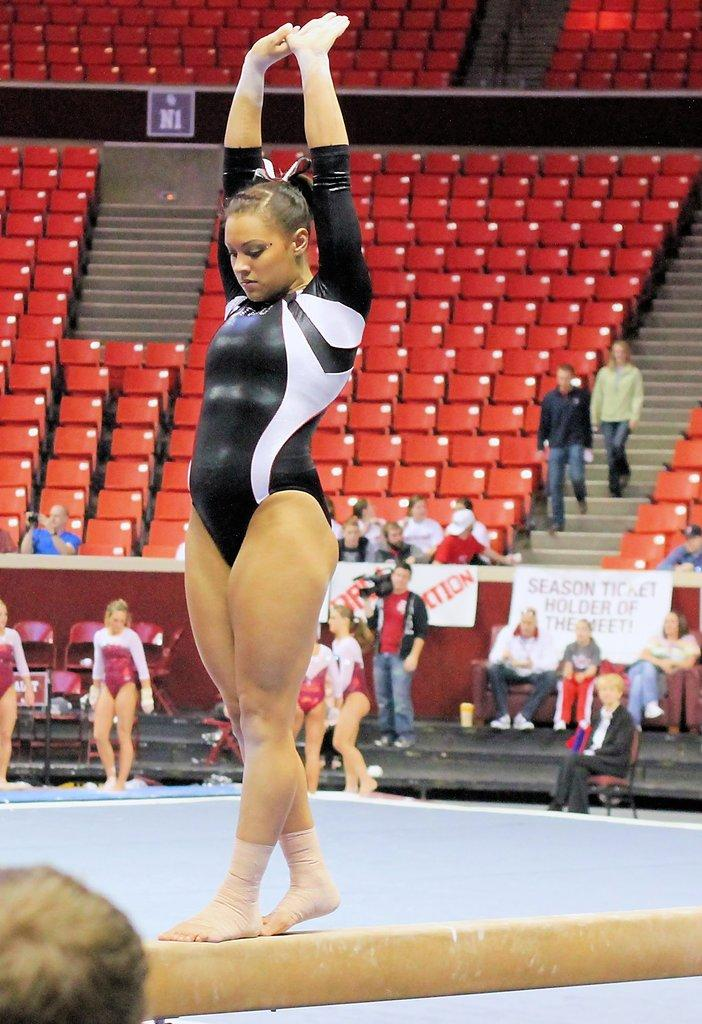Who is the main subject in the image? There is a woman in the image. What is the woman wearing? The woman is wearing a black dress. What is the woman doing in the image? The woman is standing on an object. Can you describe the background of the image? There are other persons in the background of the image. What type of polish is the woman applying to her nails in the image? There is no indication in the image that the woman is applying any polish to her nails. 